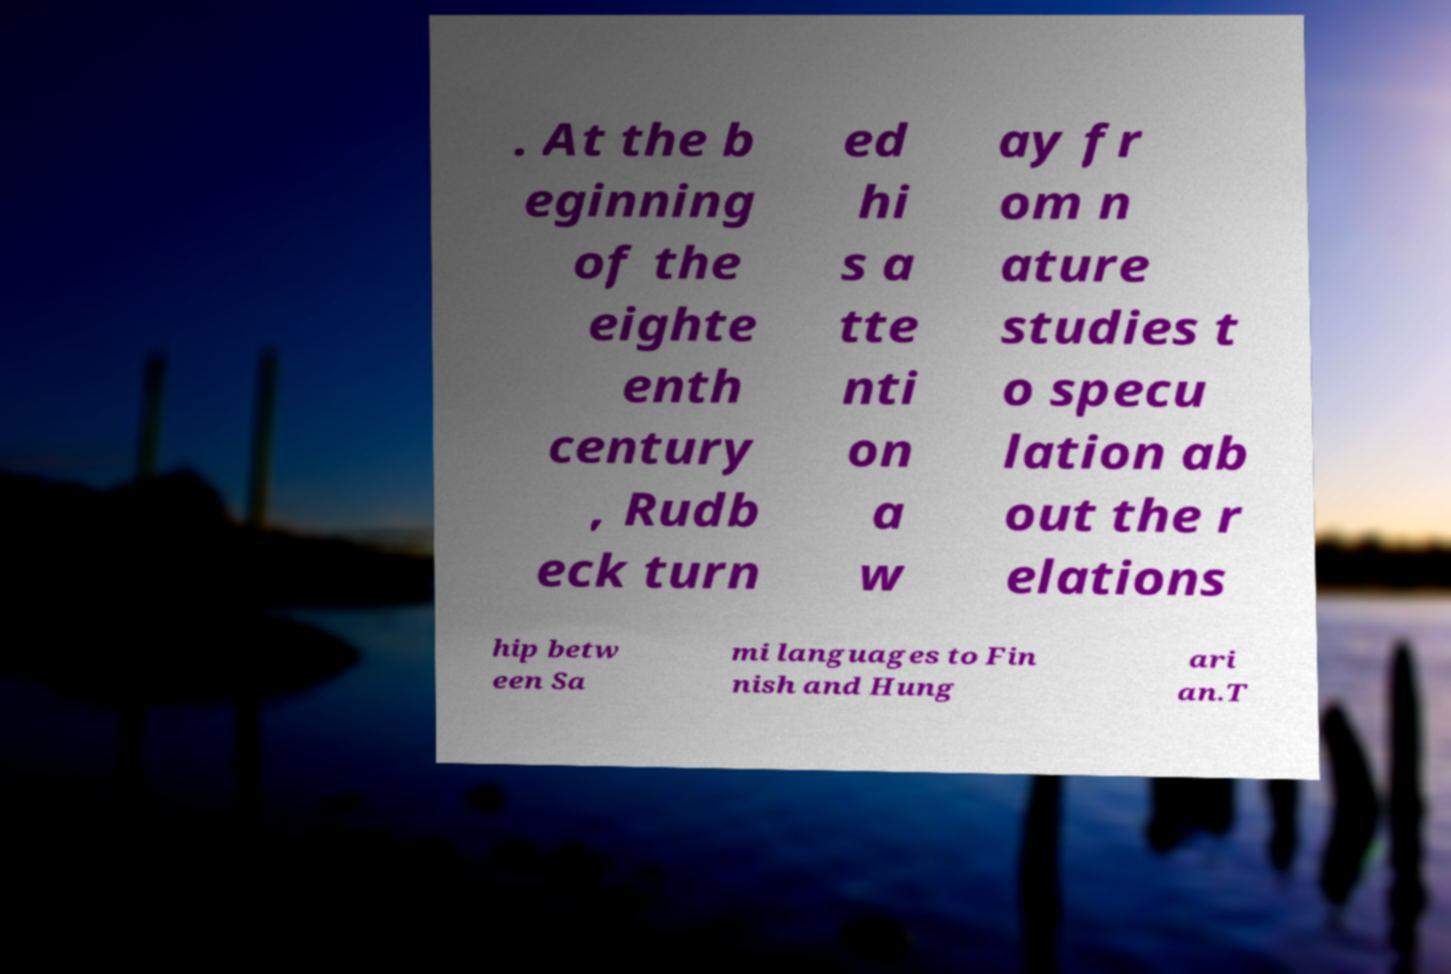For documentation purposes, I need the text within this image transcribed. Could you provide that? . At the b eginning of the eighte enth century , Rudb eck turn ed hi s a tte nti on a w ay fr om n ature studies t o specu lation ab out the r elations hip betw een Sa mi languages to Fin nish and Hung ari an.T 